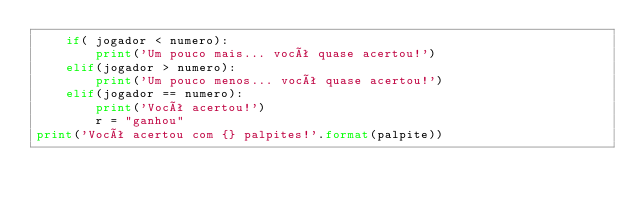<code> <loc_0><loc_0><loc_500><loc_500><_Python_>    if( jogador < numero):
        print('Um pouco mais... você quase acertou!')
    elif(jogador > numero):
        print('Um pouco menos... você quase acertou!')
    elif(jogador == numero):
        print('Você acertou!')
        r = "ganhou"
print('Você acertou com {} palpites!'.format(palpite))

</code> 